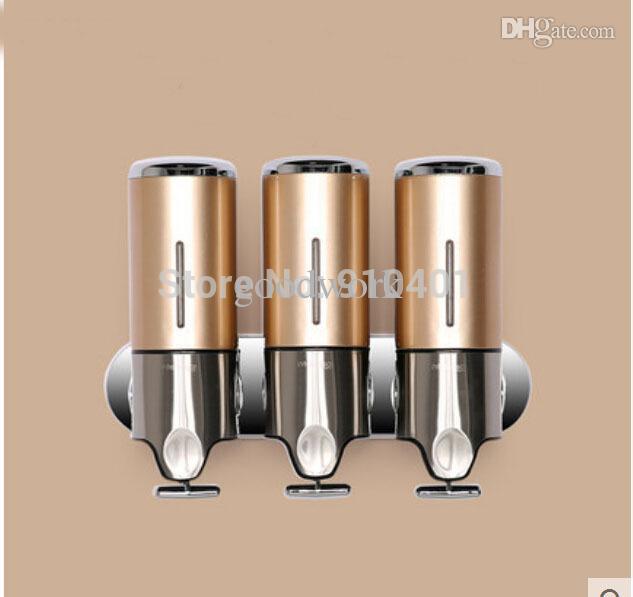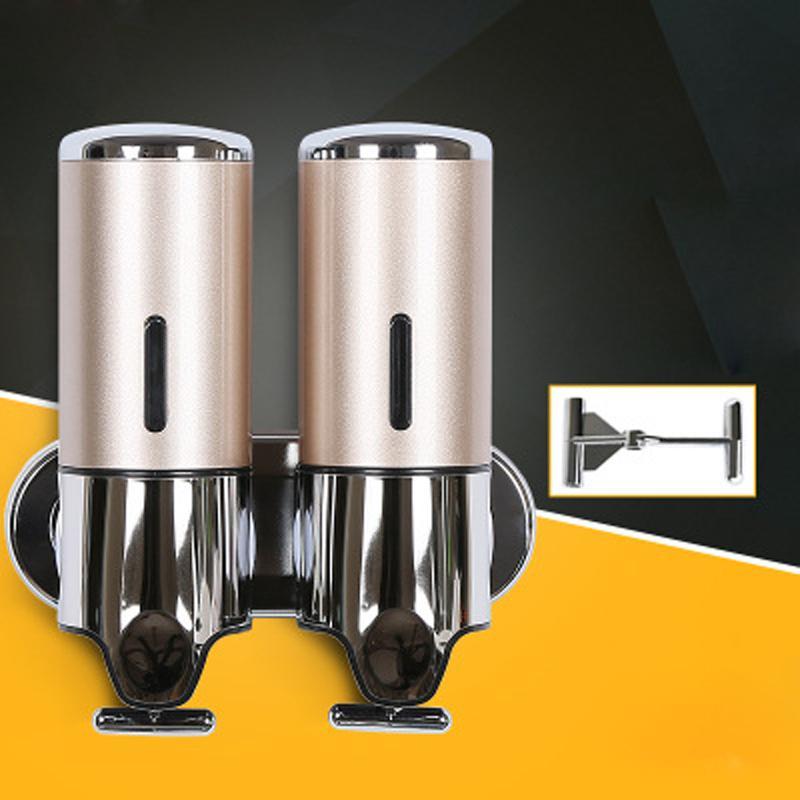The first image is the image on the left, the second image is the image on the right. Assess this claim about the two images: "The left image contains a human hand.". Correct or not? Answer yes or no. No. 